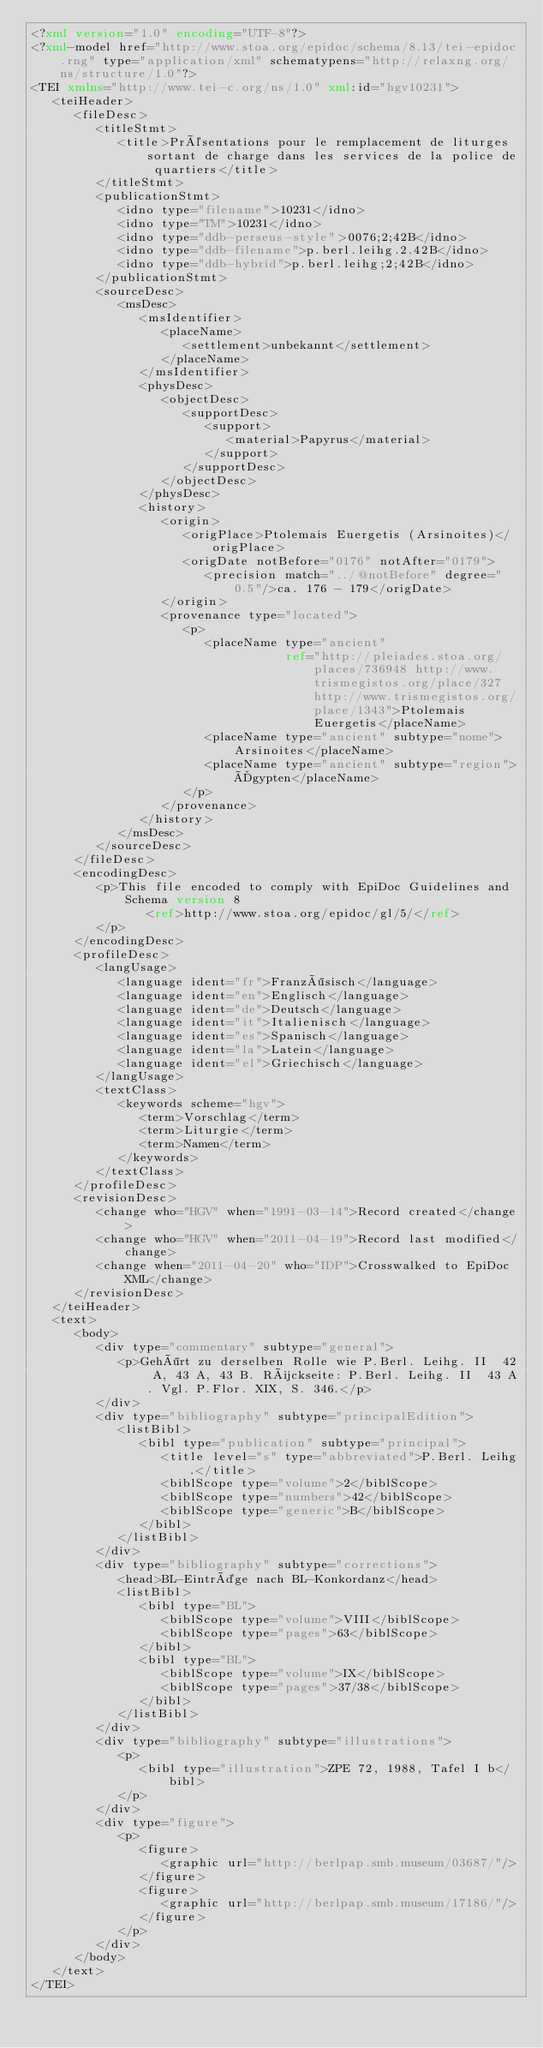<code> <loc_0><loc_0><loc_500><loc_500><_XML_><?xml version="1.0" encoding="UTF-8"?>
<?xml-model href="http://www.stoa.org/epidoc/schema/8.13/tei-epidoc.rng" type="application/xml" schematypens="http://relaxng.org/ns/structure/1.0"?>
<TEI xmlns="http://www.tei-c.org/ns/1.0" xml:id="hgv10231">
   <teiHeader>
      <fileDesc>
         <titleStmt>
            <title>Présentations pour le remplacement de liturges sortant de charge dans les services de la police de quartiers</title>
         </titleStmt>
         <publicationStmt>
            <idno type="filename">10231</idno>
            <idno type="TM">10231</idno>
            <idno type="ddb-perseus-style">0076;2;42B</idno>
            <idno type="ddb-filename">p.berl.leihg.2.42B</idno>
            <idno type="ddb-hybrid">p.berl.leihg;2;42B</idno>
         </publicationStmt>
         <sourceDesc>
            <msDesc>
               <msIdentifier>
                  <placeName>
                     <settlement>unbekannt</settlement>
                  </placeName>
               </msIdentifier>
               <physDesc>
                  <objectDesc>
                     <supportDesc>
                        <support>
                           <material>Papyrus</material>
                        </support>
                     </supportDesc>
                  </objectDesc>
               </physDesc>
               <history>
                  <origin>
                     <origPlace>Ptolemais Euergetis (Arsinoites)</origPlace>
                     <origDate notBefore="0176" notAfter="0179">
                        <precision match="../@notBefore" degree="0.5"/>ca. 176 - 179</origDate>
                  </origin>
                  <provenance type="located">
                     <p>
                        <placeName type="ancient"
                                   ref="http://pleiades.stoa.org/places/736948 http://www.trismegistos.org/place/327 http://www.trismegistos.org/place/1343">Ptolemais Euergetis</placeName>
                        <placeName type="ancient" subtype="nome">Arsinoites</placeName>
                        <placeName type="ancient" subtype="region">Ägypten</placeName>
                     </p>
                  </provenance>
               </history>
            </msDesc>
         </sourceDesc>
      </fileDesc>
      <encodingDesc>
         <p>This file encoded to comply with EpiDoc Guidelines and Schema version 8
                <ref>http://www.stoa.org/epidoc/gl/5/</ref>
         </p>
      </encodingDesc>
      <profileDesc>
         <langUsage>
            <language ident="fr">Französisch</language>
            <language ident="en">Englisch</language>
            <language ident="de">Deutsch</language>
            <language ident="it">Italienisch</language>
            <language ident="es">Spanisch</language>
            <language ident="la">Latein</language>
            <language ident="el">Griechisch</language>
         </langUsage>
         <textClass>
            <keywords scheme="hgv">
               <term>Vorschlag</term>
               <term>Liturgie</term>
               <term>Namen</term>
            </keywords>
         </textClass>
      </profileDesc>
      <revisionDesc>
         <change who="HGV" when="1991-03-14">Record created</change>
         <change who="HGV" when="2011-04-19">Record last modified</change>
         <change when="2011-04-20" who="IDP">Crosswalked to EpiDoc XML</change>
      </revisionDesc>
   </teiHeader>
   <text>
      <body>
         <div type="commentary" subtype="general">
            <p>Gehört zu derselben Rolle wie P.Berl. Leihg. II  42 A, 43 A, 43 B. Rückseite: P.Berl. Leihg. II  43 A. Vgl. P.Flor. XIX, S. 346.</p>
         </div>
         <div type="bibliography" subtype="principalEdition">
            <listBibl>
               <bibl type="publication" subtype="principal">
                  <title level="s" type="abbreviated">P.Berl. Leihg.</title>
                  <biblScope type="volume">2</biblScope>
                  <biblScope type="numbers">42</biblScope>
                  <biblScope type="generic">B</biblScope>
               </bibl>
            </listBibl>
         </div>
         <div type="bibliography" subtype="corrections">
            <head>BL-Einträge nach BL-Konkordanz</head>
            <listBibl>
               <bibl type="BL">
                  <biblScope type="volume">VIII</biblScope>
                  <biblScope type="pages">63</biblScope>
               </bibl>
               <bibl type="BL">
                  <biblScope type="volume">IX</biblScope>
                  <biblScope type="pages">37/38</biblScope>
               </bibl>
            </listBibl>
         </div>
         <div type="bibliography" subtype="illustrations">
            <p>
               <bibl type="illustration">ZPE 72, 1988, Tafel I b</bibl>
            </p>
         </div>
         <div type="figure">
            <p>
               <figure>
                  <graphic url="http://berlpap.smb.museum/03687/"/>
               </figure>
               <figure>
                  <graphic url="http://berlpap.smb.museum/17186/"/>
               </figure>
            </p>
         </div>
      </body>
   </text>
</TEI>
</code> 